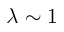<formula> <loc_0><loc_0><loc_500><loc_500>\lambda \sim 1</formula> 